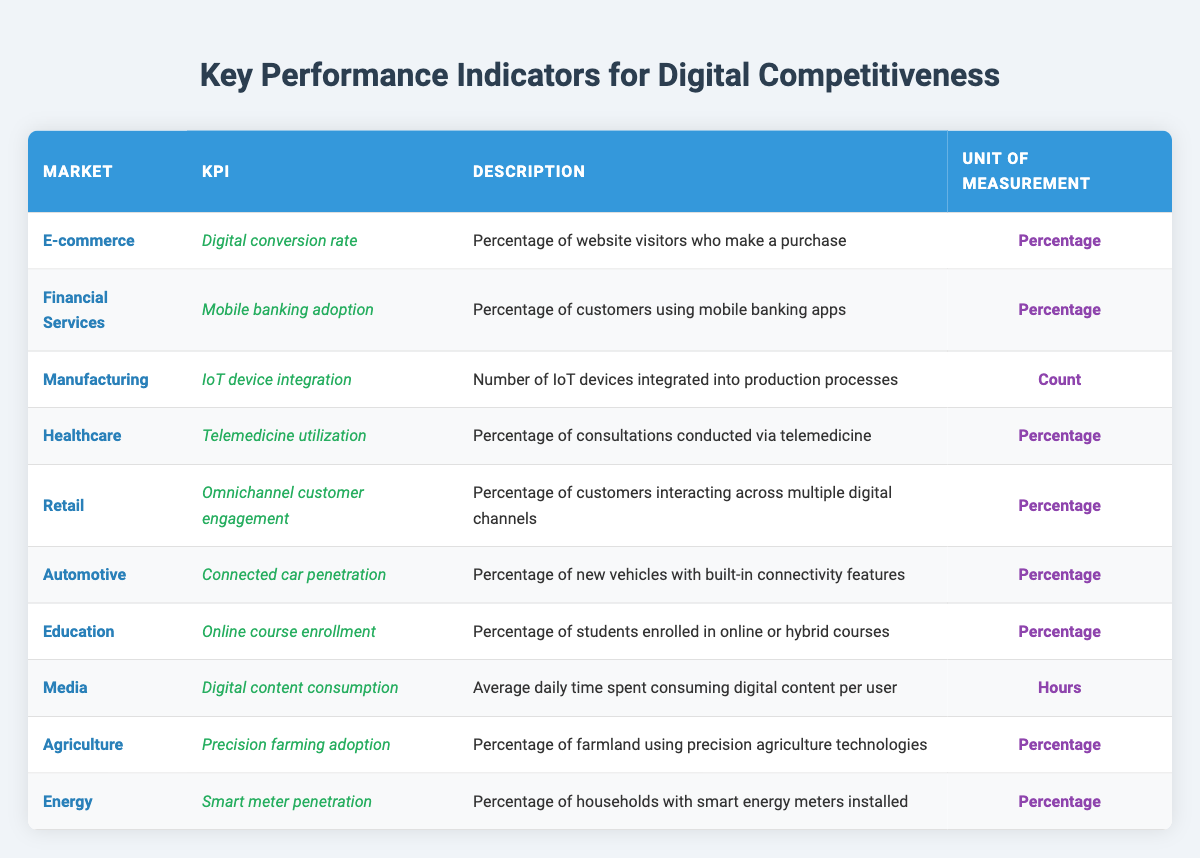What is the KPI used in the E-commerce market? The table lists the KPI for the E-commerce market as "Digital conversion rate." This is directly retrieved from the "KPI" column in the row specifying the E-commerce market.
Answer: Digital conversion rate Which market has the KPI for telemedicine utilization? By checking the table, we find that "Telemedicine utilization" is the KPI listed under the "Healthcare" market. This information can be located under the relevant row.
Answer: Healthcare Is the unit of measurement for IoT device integration in the Manufacturing sector a percentage? The table shows that the unit of measurement for "IoT device integration" in the Manufacturing sector is "Count," not a percentage. Thus, the answer is based on direct observation from the table.
Answer: No What percentage of households in the Energy sector have smart meters installed? The table notes "Smart meter penetration" as the KPI for the Energy sector, but it does not specify the actual percentage. Therefore, the information is not directly answerably based on the given data in the table.
Answer: Not available Which market has the highest digital content consumption? The table indicates that the KPI for Media is "Digital content consumption," measured in hours. However, it does not provide specific values to compare with other markets, so this cannot be concluded without additional data.
Answer: Not available What is the average percentage of mobile banking adoption in Financial Services and smart meter penetration in the Energy sector? The table includes the Mobile banking adoption as a KPI in the Financial Services sector but lists the percentage for Smart meter penetration without numerical data for either KPI. Thus, we can't compute an average or comparison.
Answer: Not available How many markets use "percentage" as a unit of measurement? In reviewing the table, the markets that use "percentage" as a unit include E-commerce, Financial Services, Healthcare, Retail, Automotive, Education, Agriculture, and Energy. Counting these results incorporates eight markets applying percentage. Therefore, the answer involves counting up all instances of "percentage" in the "Unit of Measurement" column.
Answer: 8 Which market has the highest integration of IoT devices? The table does not indicate a specific number or percentage for the number of IoT devices integrated into production processes under the Manufacturing market. As such, it does not allow for comparisons or determining which market excels.
Answer: Not available Which market shows the least digital engagement through telemedicine? While the table presents "Telemedicine utilization" as a KPI for Healthcare, it does not provide comparative data to assess levels of digital engagement relative to other markets. Thus, deducing which market shows the least engagement through this metric is not possible.
Answer: Not available 